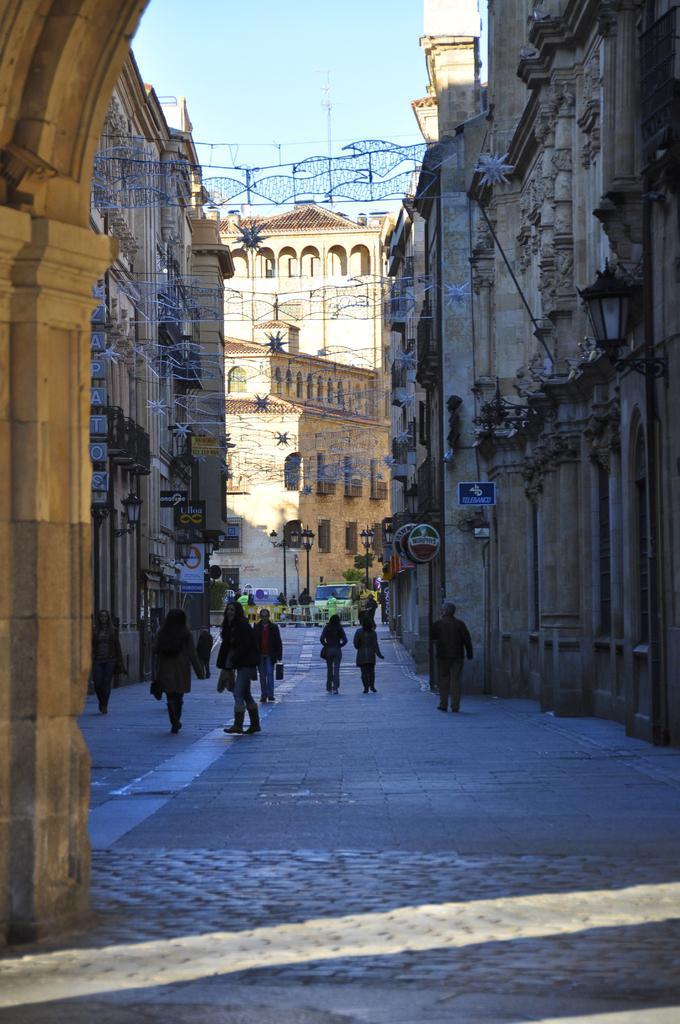Can you describe this image briefly? In this image, I can see few people on the path and lot of buildings over here and few street lights. In the background there is the sky. 